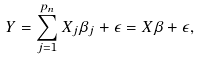Convert formula to latex. <formula><loc_0><loc_0><loc_500><loc_500>Y = \sum _ { j = 1 } ^ { p _ { n } } X _ { j } \beta _ { j } + \epsilon = X \beta + \epsilon ,</formula> 